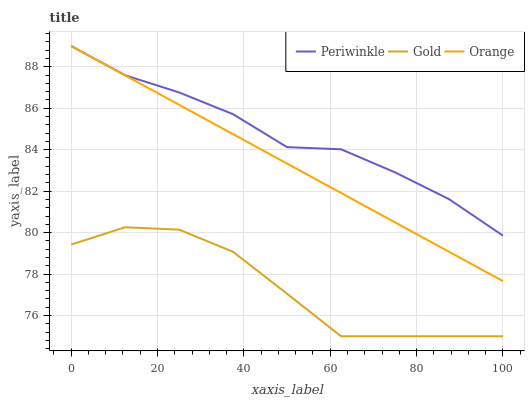Does Gold have the minimum area under the curve?
Answer yes or no. Yes. Does Periwinkle have the maximum area under the curve?
Answer yes or no. Yes. Does Periwinkle have the minimum area under the curve?
Answer yes or no. No. Does Gold have the maximum area under the curve?
Answer yes or no. No. Is Orange the smoothest?
Answer yes or no. Yes. Is Gold the roughest?
Answer yes or no. Yes. Is Periwinkle the smoothest?
Answer yes or no. No. Is Periwinkle the roughest?
Answer yes or no. No. Does Gold have the lowest value?
Answer yes or no. Yes. Does Periwinkle have the lowest value?
Answer yes or no. No. Does Periwinkle have the highest value?
Answer yes or no. Yes. Does Gold have the highest value?
Answer yes or no. No. Is Gold less than Periwinkle?
Answer yes or no. Yes. Is Orange greater than Gold?
Answer yes or no. Yes. Does Orange intersect Periwinkle?
Answer yes or no. Yes. Is Orange less than Periwinkle?
Answer yes or no. No. Is Orange greater than Periwinkle?
Answer yes or no. No. Does Gold intersect Periwinkle?
Answer yes or no. No. 